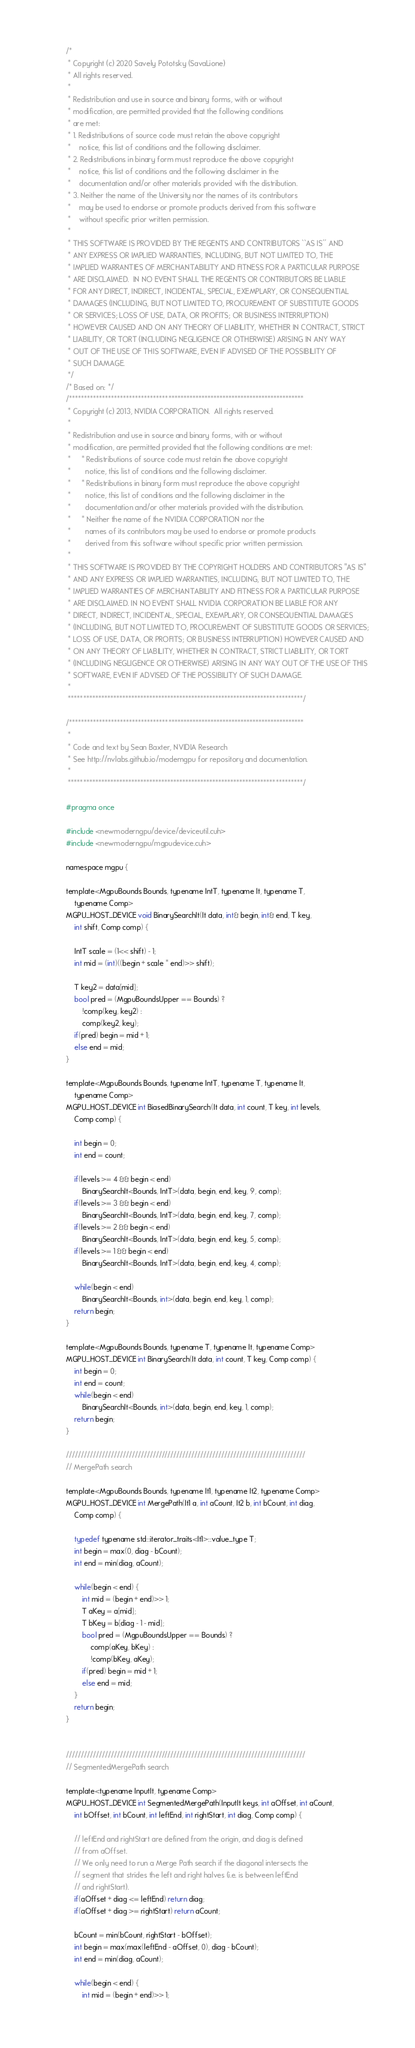<code> <loc_0><loc_0><loc_500><loc_500><_Cuda_>/*
 * Copyright (c) 2020 Savely Pototsky (SavaLione)
 * All rights reserved.
 *
 * Redistribution and use in source and binary forms, with or without
 * modification, are permitted provided that the following conditions
 * are met:
 * 1. Redistributions of source code must retain the above copyright
 *    notice, this list of conditions and the following disclaimer.
 * 2. Redistributions in binary form must reproduce the above copyright
 *    notice, this list of conditions and the following disclaimer in the
 *    documentation and/or other materials provided with the distribution.
 * 3. Neither the name of the University nor the names of its contributors
 *    may be used to endorse or promote products derived from this software
 *    without specific prior written permission.
 *
 * THIS SOFTWARE IS PROVIDED BY THE REGENTS AND CONTRIBUTORS ``AS IS'' AND
 * ANY EXPRESS OR IMPLIED WARRANTIES, INCLUDING, BUT NOT LIMITED TO, THE
 * IMPLIED WARRANTIES OF MERCHANTABILITY AND FITNESS FOR A PARTICULAR PURPOSE
 * ARE DISCLAIMED.  IN NO EVENT SHALL THE REGENTS OR CONTRIBUTORS BE LIABLE
 * FOR ANY DIRECT, INDIRECT, INCIDENTAL, SPECIAL, EXEMPLARY, OR CONSEQUENTIAL
 * DAMAGES (INCLUDING, BUT NOT LIMITED TO, PROCUREMENT OF SUBSTITUTE GOODS
 * OR SERVICES; LOSS OF USE, DATA, OR PROFITS; OR BUSINESS INTERRUPTION)
 * HOWEVER CAUSED AND ON ANY THEORY OF LIABILITY, WHETHER IN CONTRACT, STRICT
 * LIABILITY, OR TORT (INCLUDING NEGLIGENCE OR OTHERWISE) ARISING IN ANY WAY
 * OUT OF THE USE OF THIS SOFTWARE, EVEN IF ADVISED OF THE POSSIBILITY OF
 * SUCH DAMAGE.
 */
/* Based on: */
/******************************************************************************
 * Copyright (c) 2013, NVIDIA CORPORATION.  All rights reserved.
 * 
 * Redistribution and use in source and binary forms, with or without
 * modification, are permitted provided that the following conditions are met:
 *     * Redistributions of source code must retain the above copyright
 *       notice, this list of conditions and the following disclaimer.
 *     * Redistributions in binary form must reproduce the above copyright
 *       notice, this list of conditions and the following disclaimer in the
 *       documentation and/or other materials provided with the distribution.
 *     * Neither the name of the NVIDIA CORPORATION nor the
 *       names of its contributors may be used to endorse or promote products
 *       derived from this software without specific prior written permission.
 * 
 * THIS SOFTWARE IS PROVIDED BY THE COPYRIGHT HOLDERS AND CONTRIBUTORS "AS IS" 
 * AND ANY EXPRESS OR IMPLIED WARRANTIES, INCLUDING, BUT NOT LIMITED TO, THE
 * IMPLIED WARRANTIES OF MERCHANTABILITY AND FITNESS FOR A PARTICULAR PURPOSE 
 * ARE DISCLAIMED. IN NO EVENT SHALL NVIDIA CORPORATION BE LIABLE FOR ANY
 * DIRECT, INDIRECT, INCIDENTAL, SPECIAL, EXEMPLARY, OR CONSEQUENTIAL DAMAGES
 * (INCLUDING, BUT NOT LIMITED TO, PROCUREMENT OF SUBSTITUTE GOODS OR SERVICES;
 * LOSS OF USE, DATA, OR PROFITS; OR BUSINESS INTERRUPTION) HOWEVER CAUSED AND
 * ON ANY THEORY OF LIABILITY, WHETHER IN CONTRACT, STRICT LIABILITY, OR TORT
 * (INCLUDING NEGLIGENCE OR OTHERWISE) ARISING IN ANY WAY OUT OF THE USE OF THIS
 * SOFTWARE, EVEN IF ADVISED OF THE POSSIBILITY OF SUCH DAMAGE.
 *
 ******************************************************************************/

/******************************************************************************
 *
 * Code and text by Sean Baxter, NVIDIA Research
 * See http://nvlabs.github.io/moderngpu for repository and documentation.
 *
 ******************************************************************************/

#pragma once

#include <newmoderngpu/device/deviceutil.cuh>
#include <newmoderngpu/mgpudevice.cuh>

namespace mgpu {

template<MgpuBounds Bounds, typename IntT, typename It, typename T, 
	typename Comp>
MGPU_HOST_DEVICE void BinarySearchIt(It data, int& begin, int& end, T key, 
	int shift, Comp comp) {

	IntT scale = (1<< shift) - 1;
	int mid = (int)((begin + scale * end)>> shift);

	T key2 = data[mid];
	bool pred = (MgpuBoundsUpper == Bounds) ? 
		!comp(key, key2) : 
		comp(key2, key);
	if(pred) begin = mid + 1;
	else end = mid;
}

template<MgpuBounds Bounds, typename IntT, typename T, typename It,
	typename Comp>
MGPU_HOST_DEVICE int BiasedBinarySearch(It data, int count, T key, int levels,
	Comp comp) {

	int begin = 0;
	int end = count;

	if(levels >= 4 && begin < end)
		BinarySearchIt<Bounds, IntT>(data, begin, end, key, 9, comp);
	if(levels >= 3 && begin < end)
		BinarySearchIt<Bounds, IntT>(data, begin, end, key, 7, comp);
	if(levels >= 2 && begin < end)
		BinarySearchIt<Bounds, IntT>(data, begin, end, key, 5, comp);
	if(levels >= 1 && begin < end)
		BinarySearchIt<Bounds, IntT>(data, begin, end, key, 4, comp);

	while(begin < end)
		BinarySearchIt<Bounds, int>(data, begin, end, key, 1, comp);
	return begin;
}

template<MgpuBounds Bounds, typename T, typename It, typename Comp>
MGPU_HOST_DEVICE int BinarySearch(It data, int count, T key, Comp comp) {
	int begin = 0;
	int end = count;
	while(begin < end) 
		BinarySearchIt<Bounds, int>(data, begin, end, key, 1, comp);
	return begin;
}

////////////////////////////////////////////////////////////////////////////////
// MergePath search

template<MgpuBounds Bounds, typename It1, typename It2, typename Comp>
MGPU_HOST_DEVICE int MergePath(It1 a, int aCount, It2 b, int bCount, int diag,
	Comp comp) {

	typedef typename std::iterator_traits<It1>::value_type T;
	int begin = max(0, diag - bCount);
	int end = min(diag, aCount);

	while(begin < end) {
		int mid = (begin + end)>> 1;
		T aKey = a[mid];
		T bKey = b[diag - 1 - mid];
		bool pred = (MgpuBoundsUpper == Bounds) ? 
			comp(aKey, bKey) : 
			!comp(bKey, aKey);
		if(pred) begin = mid + 1;
		else end = mid;
	}
	return begin;
}


////////////////////////////////////////////////////////////////////////////////
// SegmentedMergePath search

template<typename InputIt, typename Comp>
MGPU_HOST_DEVICE int SegmentedMergePath(InputIt keys, int aOffset, int aCount,
	int bOffset, int bCount, int leftEnd, int rightStart, int diag, Comp comp) {

	// leftEnd and rightStart are defined from the origin, and diag is defined
	// from aOffset.
	// We only need to run a Merge Path search if the diagonal intersects the
	// segment that strides the left and right halves (i.e. is between leftEnd
	// and rightStart).
	if(aOffset + diag <= leftEnd) return diag;
	if(aOffset + diag >= rightStart) return aCount;

	bCount = min(bCount, rightStart - bOffset);
	int begin = max(max(leftEnd - aOffset, 0), diag - bCount);
	int end = min(diag, aCount);

	while(begin < end) {
		int mid = (begin + end)>> 1;</code> 